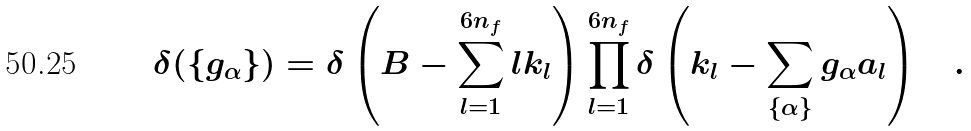<formula> <loc_0><loc_0><loc_500><loc_500>\delta ( \{ g _ { \alpha } \} ) = \delta \left ( B - \sum _ { l = 1 } ^ { 6 n _ { f } } l k _ { l } \right ) \prod _ { l = 1 } ^ { 6 n _ { f } } \delta \left ( k _ { l } - \sum _ { \{ \alpha \} } g _ { \alpha } a _ { l } \right ) \quad .</formula> 